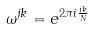Convert formula to latex. <formula><loc_0><loc_0><loc_500><loc_500>\omega ^ { j k } = e ^ { 2 \pi i \frac { j k } { N } }</formula> 